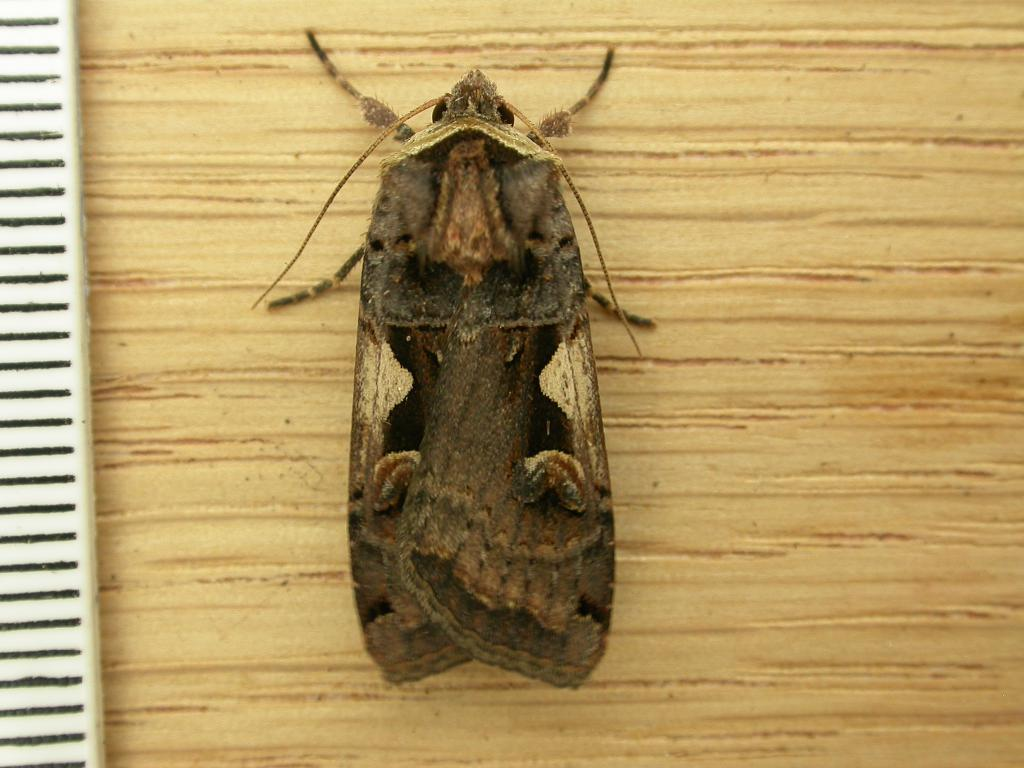What type of creature can be seen in the image? There is an insect in the image. Where is the insect located? The insect is on a wooden board. What type of glove is the insect wearing in the image? There is no glove present in the image, and insects do not wear gloves. 